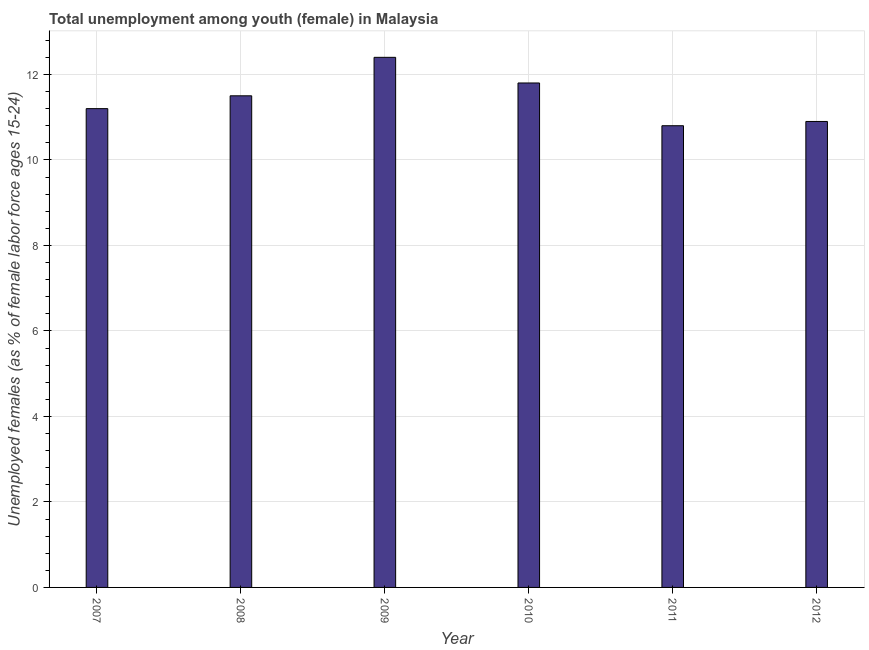What is the title of the graph?
Offer a very short reply. Total unemployment among youth (female) in Malaysia. What is the label or title of the X-axis?
Give a very brief answer. Year. What is the label or title of the Y-axis?
Give a very brief answer. Unemployed females (as % of female labor force ages 15-24). What is the unemployed female youth population in 2012?
Provide a short and direct response. 10.9. Across all years, what is the maximum unemployed female youth population?
Your response must be concise. 12.4. Across all years, what is the minimum unemployed female youth population?
Make the answer very short. 10.8. In which year was the unemployed female youth population maximum?
Provide a short and direct response. 2009. What is the sum of the unemployed female youth population?
Keep it short and to the point. 68.6. What is the average unemployed female youth population per year?
Give a very brief answer. 11.43. What is the median unemployed female youth population?
Offer a terse response. 11.35. Is the unemployed female youth population in 2009 less than that in 2010?
Provide a short and direct response. No. Is the difference between the unemployed female youth population in 2008 and 2009 greater than the difference between any two years?
Give a very brief answer. No. What is the difference between the highest and the second highest unemployed female youth population?
Provide a short and direct response. 0.6. What is the difference between the highest and the lowest unemployed female youth population?
Keep it short and to the point. 1.6. In how many years, is the unemployed female youth population greater than the average unemployed female youth population taken over all years?
Your answer should be very brief. 3. Are all the bars in the graph horizontal?
Your answer should be very brief. No. How many years are there in the graph?
Provide a succinct answer. 6. What is the difference between two consecutive major ticks on the Y-axis?
Offer a terse response. 2. What is the Unemployed females (as % of female labor force ages 15-24) of 2007?
Ensure brevity in your answer.  11.2. What is the Unemployed females (as % of female labor force ages 15-24) of 2009?
Keep it short and to the point. 12.4. What is the Unemployed females (as % of female labor force ages 15-24) in 2010?
Provide a short and direct response. 11.8. What is the Unemployed females (as % of female labor force ages 15-24) of 2011?
Your answer should be very brief. 10.8. What is the Unemployed females (as % of female labor force ages 15-24) in 2012?
Ensure brevity in your answer.  10.9. What is the difference between the Unemployed females (as % of female labor force ages 15-24) in 2007 and 2008?
Offer a very short reply. -0.3. What is the difference between the Unemployed females (as % of female labor force ages 15-24) in 2008 and 2012?
Your response must be concise. 0.6. What is the difference between the Unemployed females (as % of female labor force ages 15-24) in 2009 and 2012?
Provide a succinct answer. 1.5. What is the difference between the Unemployed females (as % of female labor force ages 15-24) in 2011 and 2012?
Offer a terse response. -0.1. What is the ratio of the Unemployed females (as % of female labor force ages 15-24) in 2007 to that in 2008?
Your answer should be very brief. 0.97. What is the ratio of the Unemployed females (as % of female labor force ages 15-24) in 2007 to that in 2009?
Give a very brief answer. 0.9. What is the ratio of the Unemployed females (as % of female labor force ages 15-24) in 2007 to that in 2010?
Your answer should be compact. 0.95. What is the ratio of the Unemployed females (as % of female labor force ages 15-24) in 2007 to that in 2012?
Offer a very short reply. 1.03. What is the ratio of the Unemployed females (as % of female labor force ages 15-24) in 2008 to that in 2009?
Ensure brevity in your answer.  0.93. What is the ratio of the Unemployed females (as % of female labor force ages 15-24) in 2008 to that in 2010?
Ensure brevity in your answer.  0.97. What is the ratio of the Unemployed females (as % of female labor force ages 15-24) in 2008 to that in 2011?
Offer a very short reply. 1.06. What is the ratio of the Unemployed females (as % of female labor force ages 15-24) in 2008 to that in 2012?
Your response must be concise. 1.05. What is the ratio of the Unemployed females (as % of female labor force ages 15-24) in 2009 to that in 2010?
Your answer should be very brief. 1.05. What is the ratio of the Unemployed females (as % of female labor force ages 15-24) in 2009 to that in 2011?
Ensure brevity in your answer.  1.15. What is the ratio of the Unemployed females (as % of female labor force ages 15-24) in 2009 to that in 2012?
Provide a short and direct response. 1.14. What is the ratio of the Unemployed females (as % of female labor force ages 15-24) in 2010 to that in 2011?
Make the answer very short. 1.09. What is the ratio of the Unemployed females (as % of female labor force ages 15-24) in 2010 to that in 2012?
Your response must be concise. 1.08. What is the ratio of the Unemployed females (as % of female labor force ages 15-24) in 2011 to that in 2012?
Give a very brief answer. 0.99. 